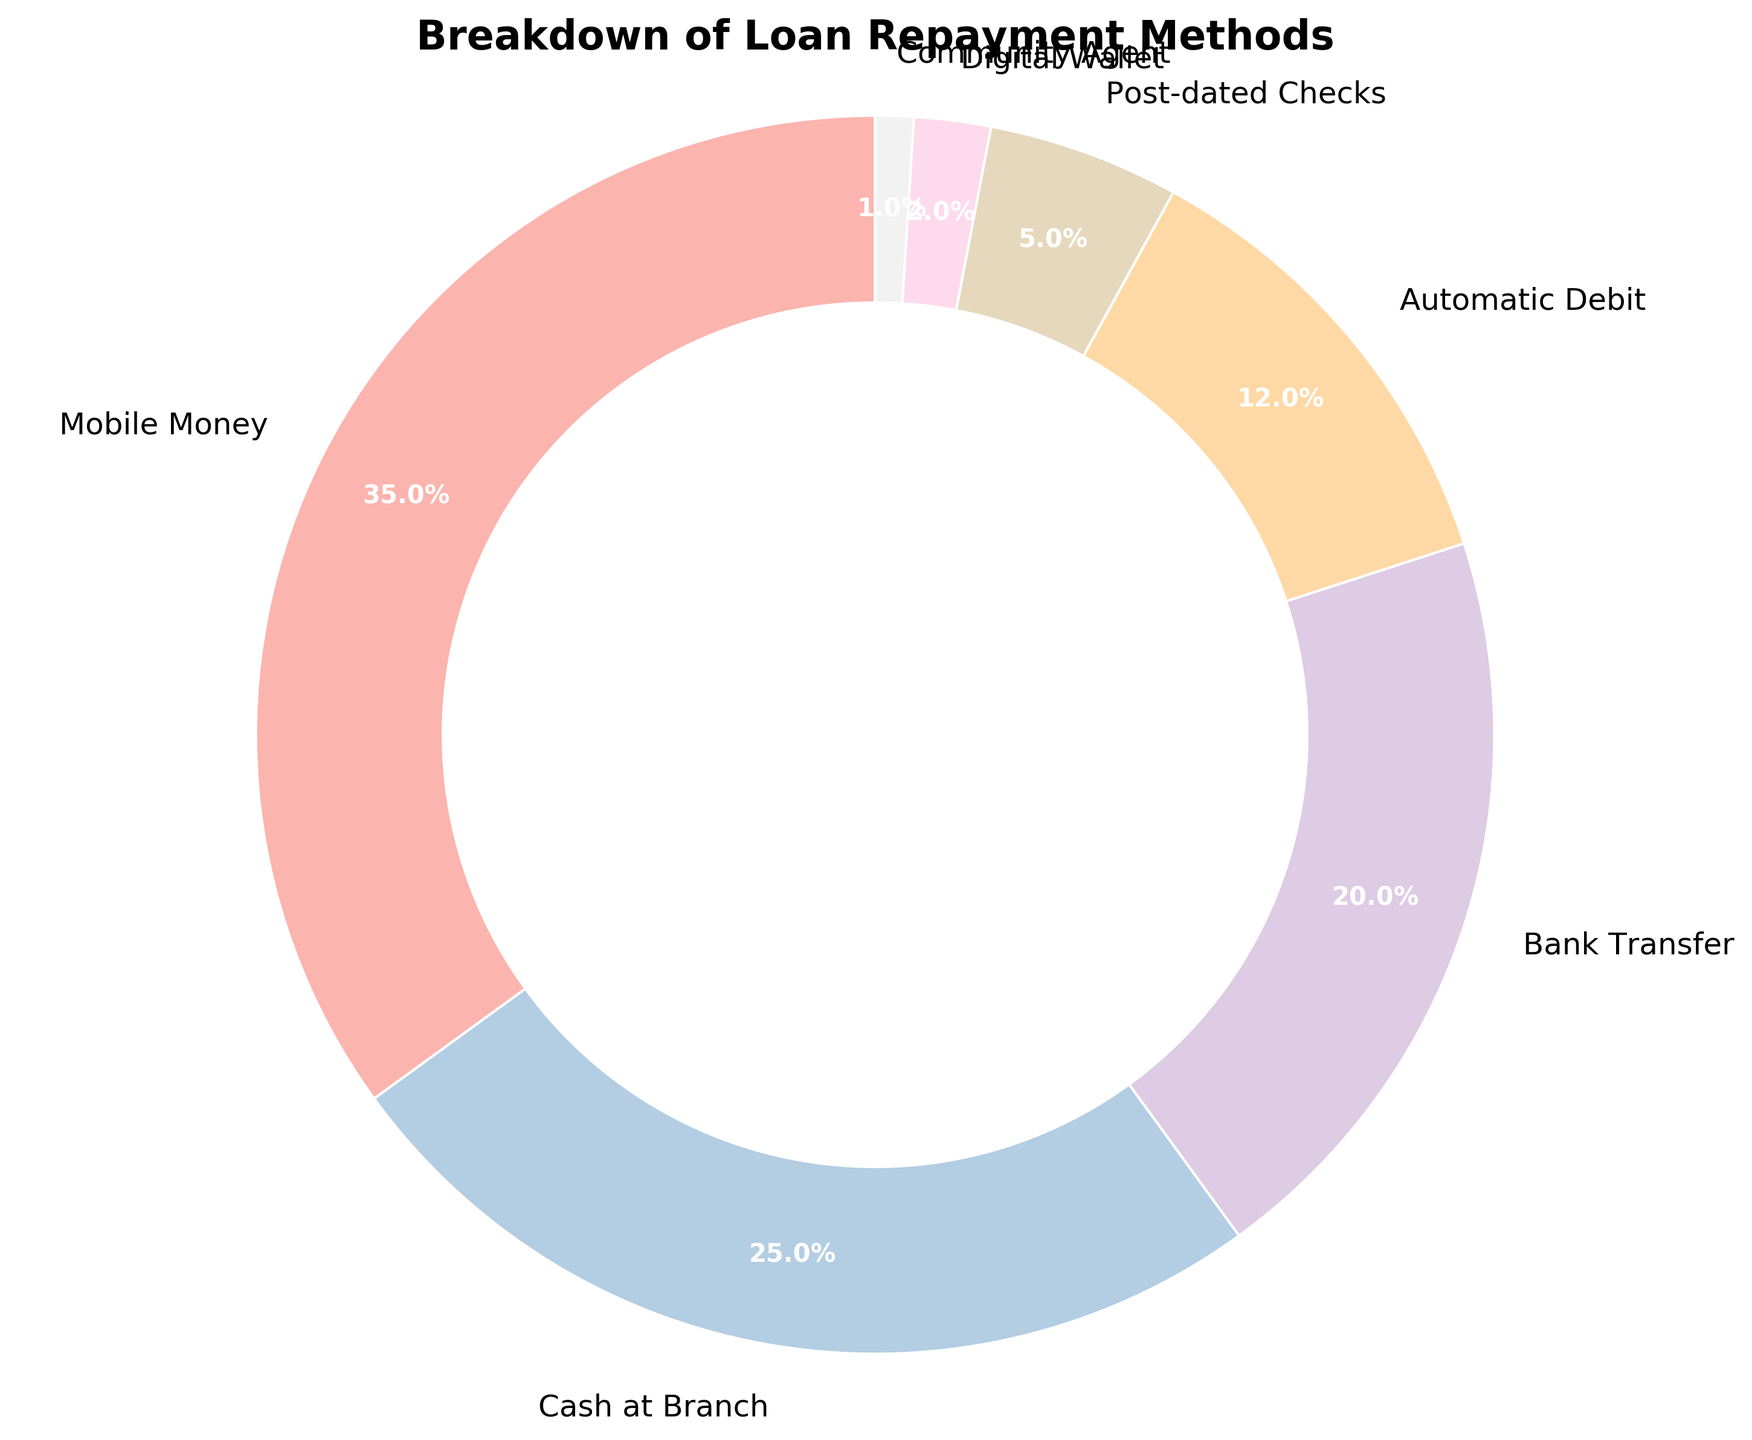What is the most commonly used loan repayment method? The most commonly used loan repayment method is the one with the highest percentage in the pie chart.
Answer: Mobile Money Which two repayment methods have the closest percentages? To find the two methods with the closest percentages, look for the smallest difference between the values.
Answer: Cash at Branch and Bank Transfer What percentage of borrowers use either Mobile Money or Automatic Debit for loan repayment? Add the percentages of Mobile Money (35%) and Automatic Debit (12%).
Answer: 47% What is the difference in the percentage between the highest and lowest used repayment methods? Subtract the percentage of the least used method (Community Agent at 1%) from the most used method (Mobile Money at 35%).
Answer: 34% Are there more borrowers using Cash at Branch or Bank Transfer methods? Compare the percentages of Cash at Branch (25%) and Bank Transfer (20%).
Answer: Cash at Branch What proportion of borrowers use digital repayment methods (Mobile Money, Automatic Debit, and Digital Wallet)? Add the percentages of Mobile Money (35%), Automatic Debit (12%), and Digital Wallet (2%).
Answer: 49% Which repayment method is used by fewer borrowers than both Bank Transfer and Automatic Debit combined? First, add the percentages of Bank Transfer (20%) and Automatic Debit (12%) to get 32%. Then, find a method with a lower percentage than this sum.
Answer: Cash at Branch How many times more do borrowers use Mobile Money compared to Digital Wallet? Divide the percentage of Mobile Money (35%) by that of Digital Wallet (2%).
Answer: 17.5 times If you were to combine the least used two methods, what would their total percentage be? Add the percentages of Digital Wallet (2%) and Community Agent (1%).
Answer: 3% Which three methods together make up more than half of the total repayment methods? Check cumulative percentages starting from the highest: Mobile Money (35%), Cash at Branch (25%) and Bank Transfer (20%), which sum to 80%.
Answer: Mobile Money, Cash at Branch, Bank Transfer 